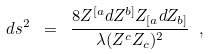<formula> <loc_0><loc_0><loc_500><loc_500>d s ^ { 2 } \ = \ \frac { 8 Z ^ { [ a } d Z ^ { b ] } Z _ { [ a } d Z _ { b ] } } { \lambda ( Z ^ { c } Z _ { c } ) ^ { 2 } } \ ,</formula> 